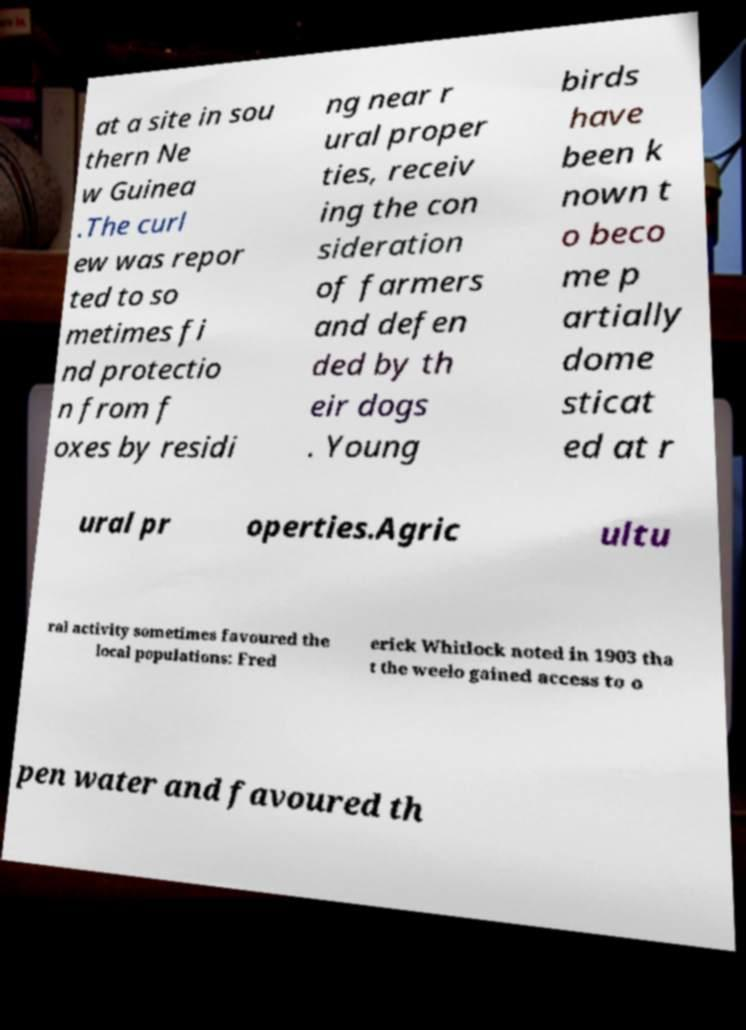Could you assist in decoding the text presented in this image and type it out clearly? at a site in sou thern Ne w Guinea .The curl ew was repor ted to so metimes fi nd protectio n from f oxes by residi ng near r ural proper ties, receiv ing the con sideration of farmers and defen ded by th eir dogs . Young birds have been k nown t o beco me p artially dome sticat ed at r ural pr operties.Agric ultu ral activity sometimes favoured the local populations: Fred erick Whitlock noted in 1903 tha t the weelo gained access to o pen water and favoured th 